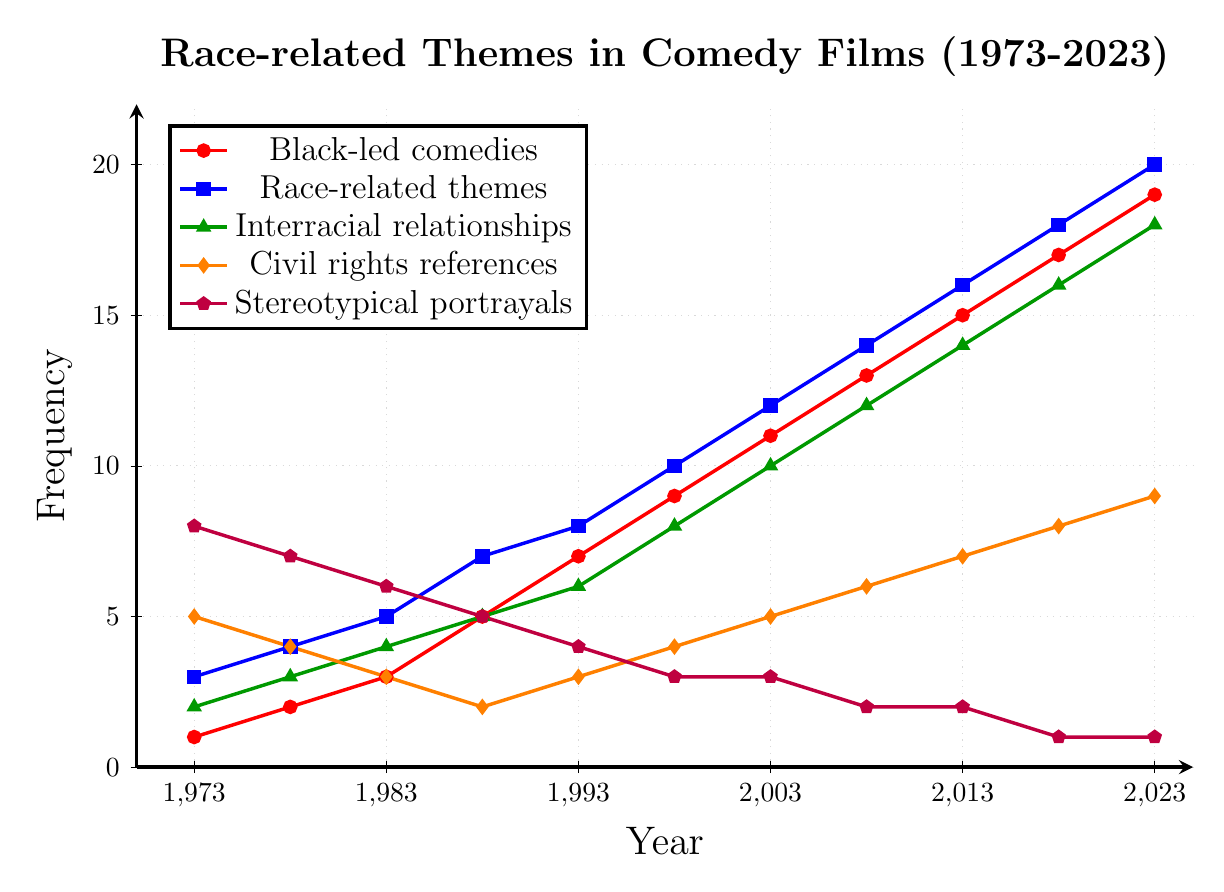How has the frequency of Black-led comedies changed from 1973 to 2023? Start by identifying the data points for Black-led comedies at 1973 (1) and 2023 (19). Subtract the initial value from the final value: 19 - 1 = 18.
Answer: The frequency increased by 18 In which year did race-related themes surpass the frequency of interracial relationships for the first time? Look at the trend lines for race-related themes (blue) and interracial relationships (green). Identify the year when the blue line first exceeds the green line: 1978 (4 vs. 3).
Answer: 1978 What has been the trend for stereotypical portrayals from 1973 to 2023? Identify the data points for stereotypical portrayals (purple), starting at 8 in 1973 and ending at 1 in 2023. This shows a declining trend.
Answer: Declining Compare the frequency of Civil Rights references in 1978 and 2023. Which year had a higher frequency, and what is the difference? Identify the Civil Rights references for 1978 (4) and 2023 (9). Subtract to find the difference: 9 - 4 = 5. 2023 had a higher frequency.
Answer: 2023, difference is 5 Which theme had the highest frequency in 2008? Review the data points for 2008 across all themes: Black-led comedies (13), Race-related themes (14), Interracial relationships (12), Civil rights references (6), Stereotypical portrayals (2). Race-related themes had the highest frequency.
Answer: Race-related themes By how much did the frequency of race-related themes increase from 1988 to 2008? Identify the data points for race-related themes in 1988 (7) and 2008 (14). Subtract the initial value from the final value: 14 - 7 = 7.
Answer: Increased by 7 What is the average frequency of Civil Rights references from 1973 to 2023? Identify the data points for Civil Rights references: 5, 4, 3, 2, 3, 4, 5, 6, 7, 8, 9. Calculate the sum: 5 + 4 + 3 + 2 + 3 + 4 + 5 + 6 + 7 + 8 + 9 = 56. Divide by the number of data points (11): 56 / 11 ≈ 5.09.
Answer: Approximately 5.09 How many years did it take for interracial relationships to double in frequency from their starting point? Identify the starting frequency for interracial relationships in 1973 (2). Look for the first instance where the frequency reaches at least 4: 1983 (4). Calculate the difference in years: 1983 - 1973 = 10 years.
Answer: 10 years Between which years did the frequency of stereotypical portrayals see the most significant drop? Compare the annual changes in stereotypical portrayals: From 8 in 1973 to 7 in 1978, and so forth. The most significant drop is between 1973 (8) and 1978 (7), showing a change of 1. The same difference exists in subsequent intervals, so we need to check which interval has the largest change: No larger interval found, stick with the largest consistent drop from 8 to 7.
Answer: 1973 to 1978 